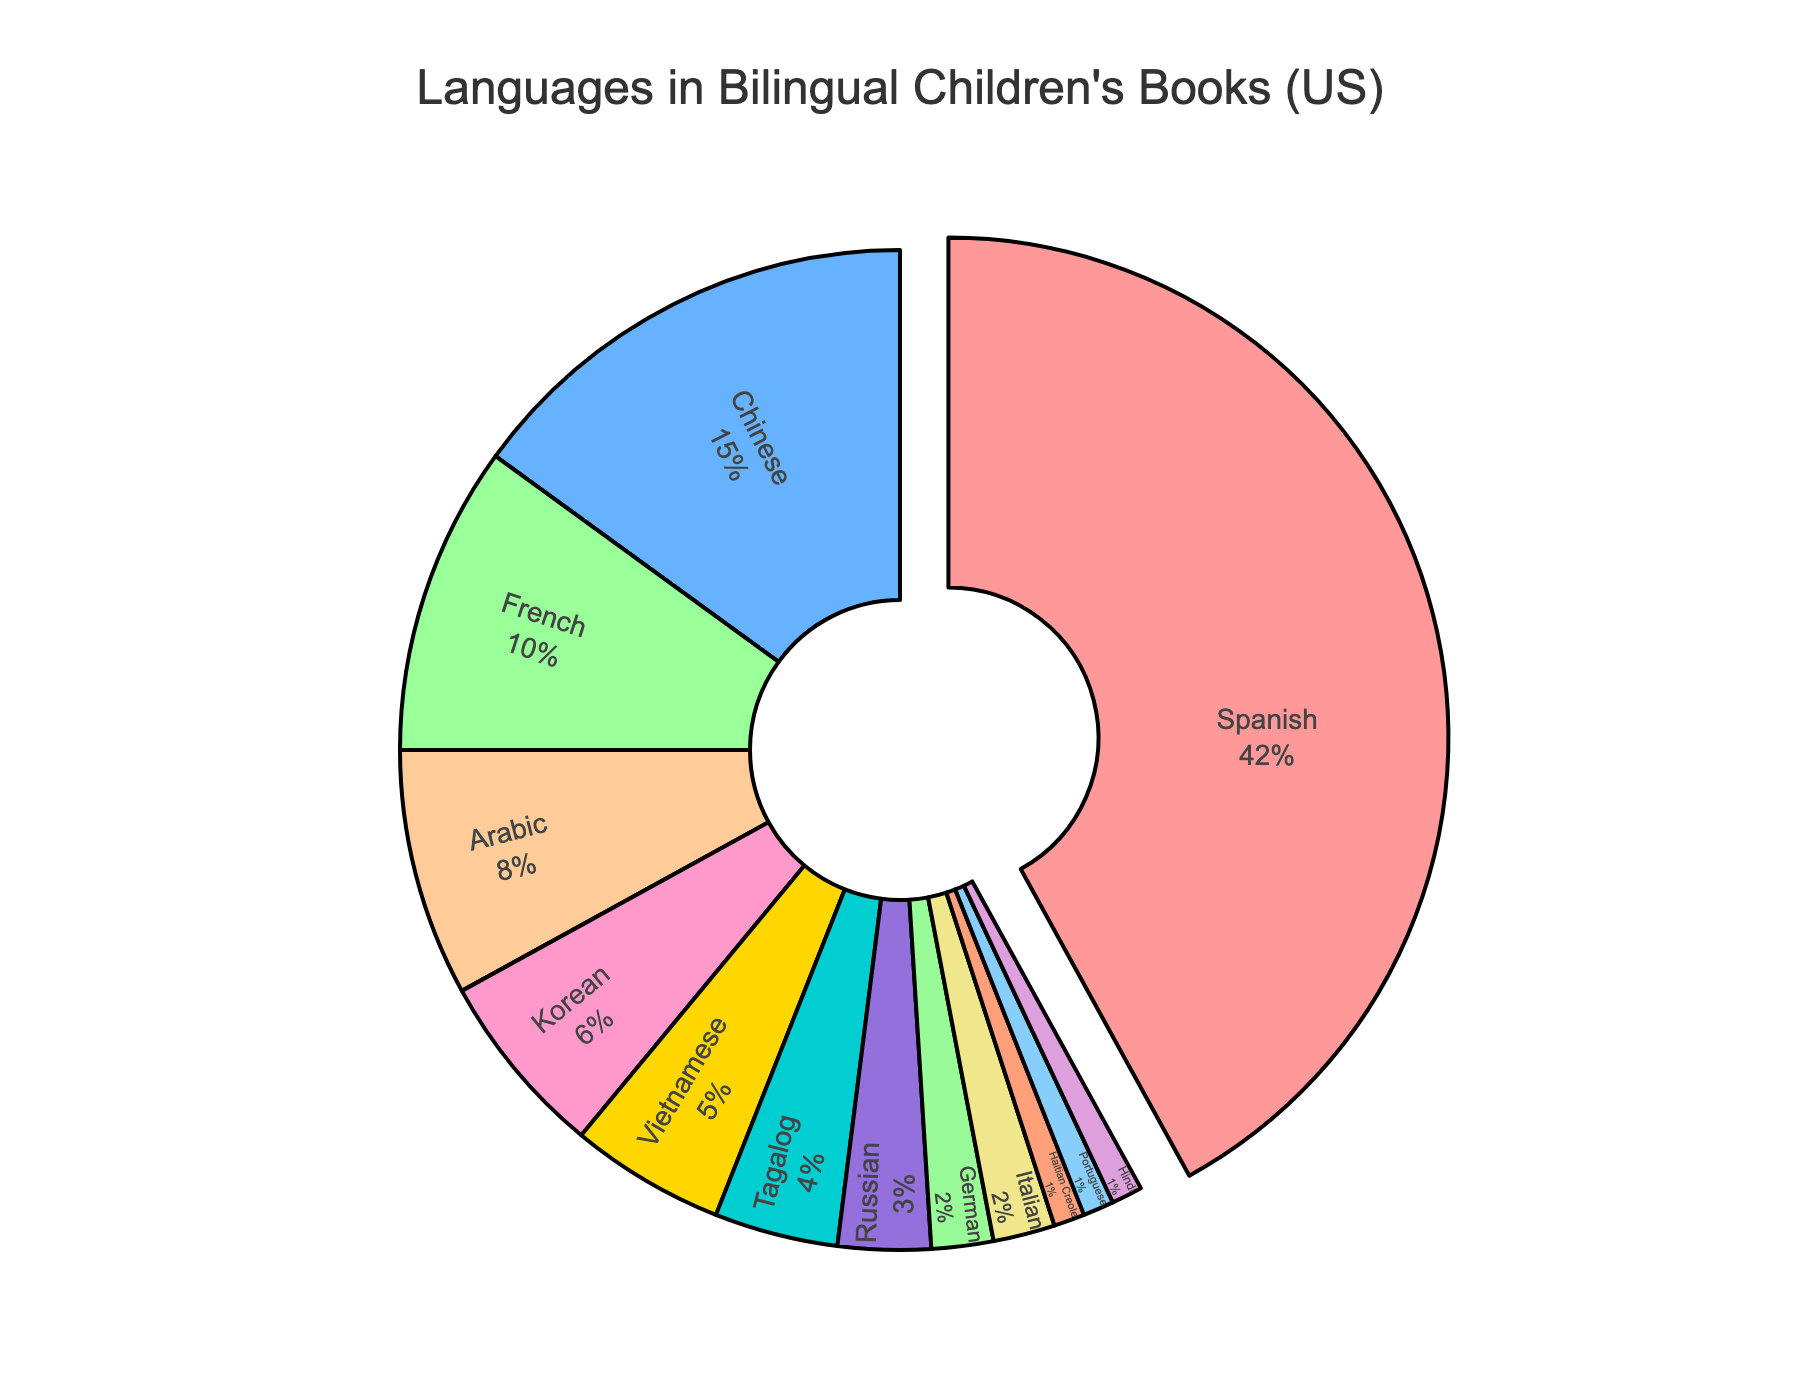What language has the largest percentage of bilingual children's books? Observing the largest segment of the pie chart, we can see that the Spanish language makes up the biggest portion.
Answer: Spanish What is the combined percentage of bilingual children's books published in Chinese and Arabic? According to the chart, the percentage for Chinese is 15% and for Arabic is 8%. Adding these together, we get 15% + 8% = 23%.
Answer: 23% Which is more prevalent in bilingual children's books: Korean or Vietnamese? Comparing the two segments, Korean makes up 6% of the chart while Vietnamese makes up 5%. Therefore, Korean is more prevalent.
Answer: Korean How much larger is the percentage of Spanish books compared to French books? The Spanish segment is 42% and the French segment is 10%. The difference is 42% - 10% = 32%.
Answer: 32% What is the percentage difference between Tagalog and Russian books? The percentage for Tagalog is 4%, and for Russian, it is 3%. The difference is 4% - 3% = 1%.
Answer: 1% Which color represents French in the pie chart? By observing the pie chart and its color-coded segments, the French language is represented by a blue segment.
Answer: Blue What is the total percentage of books in German and Italian combined? Both German and Italian have a percentage of 2% each. Adding these together, we get 2% + 2% = 4%.
Answer: 4% Is the percentage of Hindi books greater than or equal to the percentage of Haitian Creole books? According to the pie chart, both Hindi and Haitian Creole books each make up 1%. Thus, the percentage of Hindi books is equal to the percentage of Haitian Creole books.
Answer: Equal What is the total percentage of languages that comprise less than 5% each? This includes Korean (6%), Vietnamese (5%), Tagalog (4%), Russian (3%), German (2%), Italian (2%), Haitian Creole (1%), Portuguese (1%), and Hindi (1%). Adding these together, we get 6% + 5% + 4% + 3% + 2% + 2% + 1% + 1% + 1% = 25%.
Answer: 25% How does the segment size of Chinese compare visually to the segment size of Arabic? The Chinese segment is larger than the Arabic segment when visually comparing the two on the pie chart.
Answer: Chinese is larger 